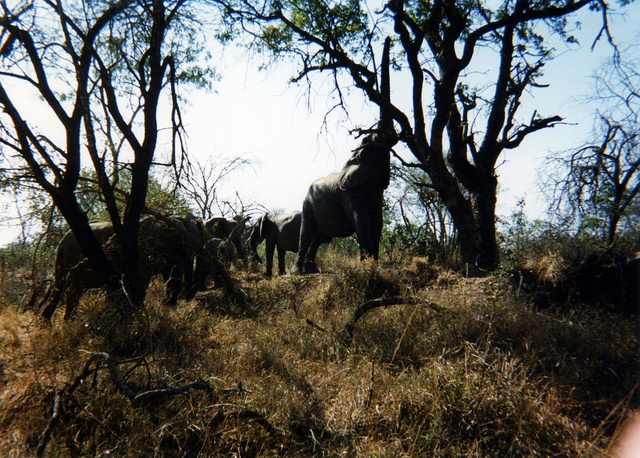Describe the objects in this image and their specific colors. I can see elephant in tan, black, gray, lightgray, and darkgray tones, elephant in tan, black, olive, maroon, and gray tones, elephant in tan, black, gray, darkgray, and lightgray tones, elephant in tan, black, gray, and darkgreen tones, and elephant in tan, black, darkgreen, darkgray, and gray tones in this image. 